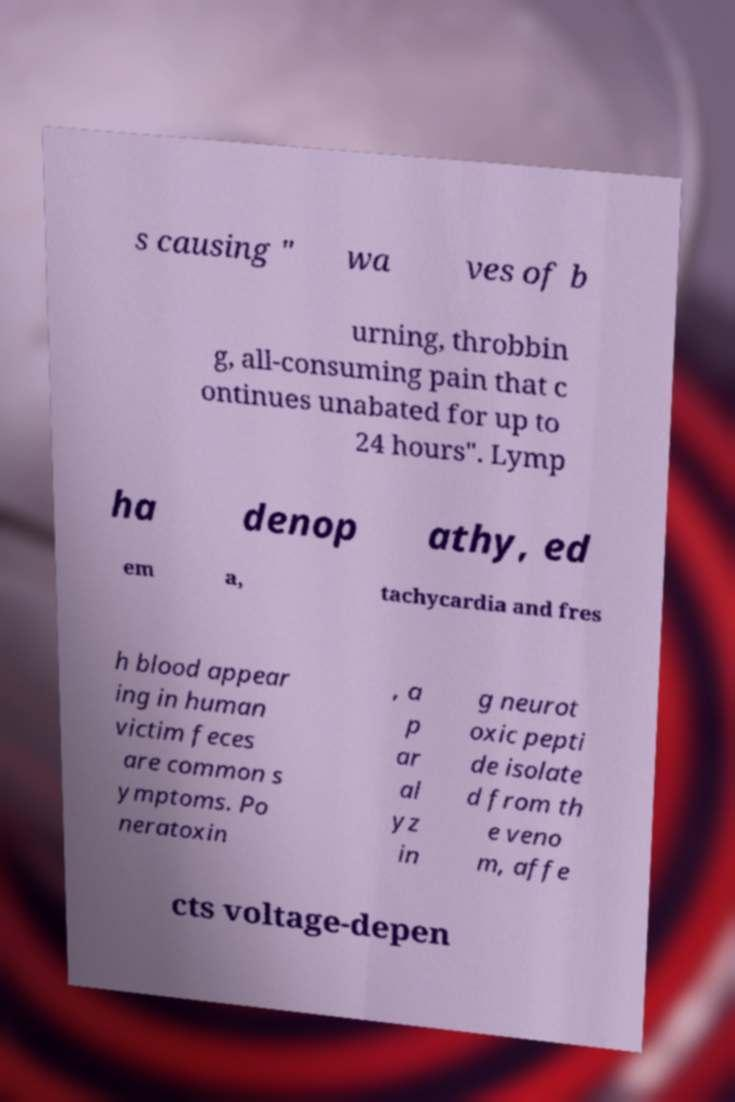Could you assist in decoding the text presented in this image and type it out clearly? s causing " wa ves of b urning, throbbin g, all-consuming pain that c ontinues unabated for up to 24 hours". Lymp ha denop athy, ed em a, tachycardia and fres h blood appear ing in human victim feces are common s ymptoms. Po neratoxin , a p ar al yz in g neurot oxic pepti de isolate d from th e veno m, affe cts voltage-depen 